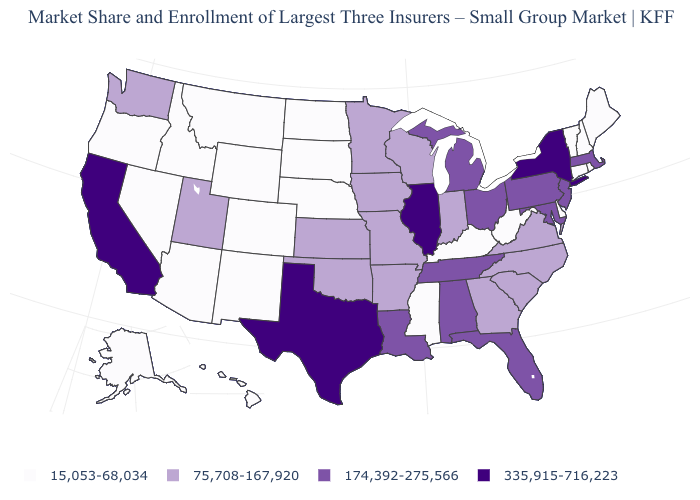What is the value of New Jersey?
Keep it brief. 174,392-275,566. Name the states that have a value in the range 174,392-275,566?
Be succinct. Alabama, Florida, Louisiana, Maryland, Massachusetts, Michigan, New Jersey, Ohio, Pennsylvania, Tennessee. Is the legend a continuous bar?
Concise answer only. No. What is the value of Louisiana?
Quick response, please. 174,392-275,566. What is the value of Colorado?
Give a very brief answer. 15,053-68,034. What is the highest value in the South ?
Short answer required. 335,915-716,223. What is the value of Oklahoma?
Keep it brief. 75,708-167,920. What is the value of Illinois?
Short answer required. 335,915-716,223. Does New Hampshire have the lowest value in the USA?
Give a very brief answer. Yes. Among the states that border Massachusetts , does Connecticut have the lowest value?
Write a very short answer. Yes. Does California have the highest value in the USA?
Quick response, please. Yes. Does Tennessee have a lower value than New York?
Answer briefly. Yes. Name the states that have a value in the range 174,392-275,566?
Concise answer only. Alabama, Florida, Louisiana, Maryland, Massachusetts, Michigan, New Jersey, Ohio, Pennsylvania, Tennessee. Which states have the lowest value in the West?
Write a very short answer. Alaska, Arizona, Colorado, Hawaii, Idaho, Montana, Nevada, New Mexico, Oregon, Wyoming. What is the value of Arizona?
Be succinct. 15,053-68,034. 